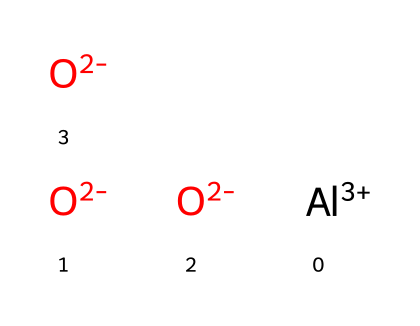What is the main metallic element in this structure? The structure shows the presence of aluminum, as indicated by the symbol 'Al' in the SMILES representation.
Answer: aluminum How many oxygen atoms are present? The SMILES representation contains three 'O' symbols, which indicate three oxygen atoms.
Answer: three What is the charge on the aluminum ion? The '+' symbol with the number '3' indicates that the aluminum ion has a charge of +3.
Answer: +3 What type of bonding is primarily present in this compound? The presence of multiple oxygen atoms with a -2 charge bonded to aluminum suggests ionic bonding, where aluminum donates electrons to oxygen.
Answer: ionic bonding Which part of this chemical indicates it can form ionic bonds? The aluminum ion has a +3 charge, while each oxygen has a -2 charge. This charge imbalance drives the formation of ionic bonds between them.
Answer: the charges What is the overall charge of this compound? To determine the overall charge, we sum the charges: +3 from aluminum and -6 from three oxygens (-2 * 3). This leads to a net charge of -3.
Answer: -3 